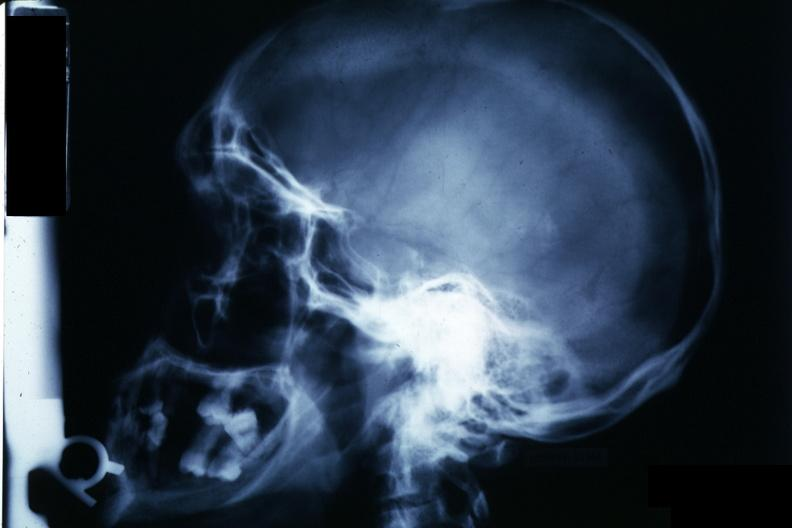s glomerulosa present?
Answer the question using a single word or phrase. No 